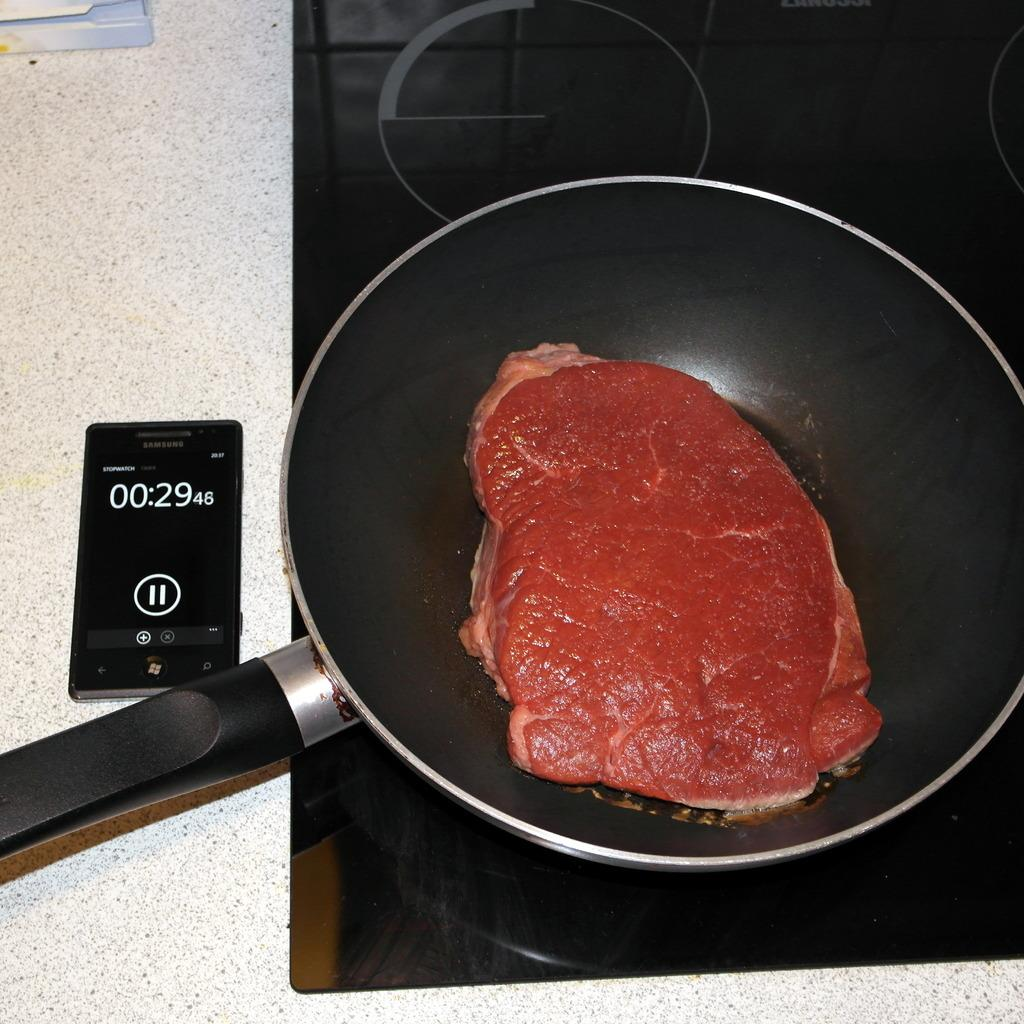What is being cooked on the pan in the image? There is meat on a pan in the image. Where is the pan placed while cooking? The pan is placed on a gas stove. What is located on the floor in the image? There is a mobile and some objects on the floor in the image. What type of worm can be seen crawling in the soup in the image? There is no soup or worm present in the image. Is the queen present in the image? There is no queen or any indication of royalty in the image. 